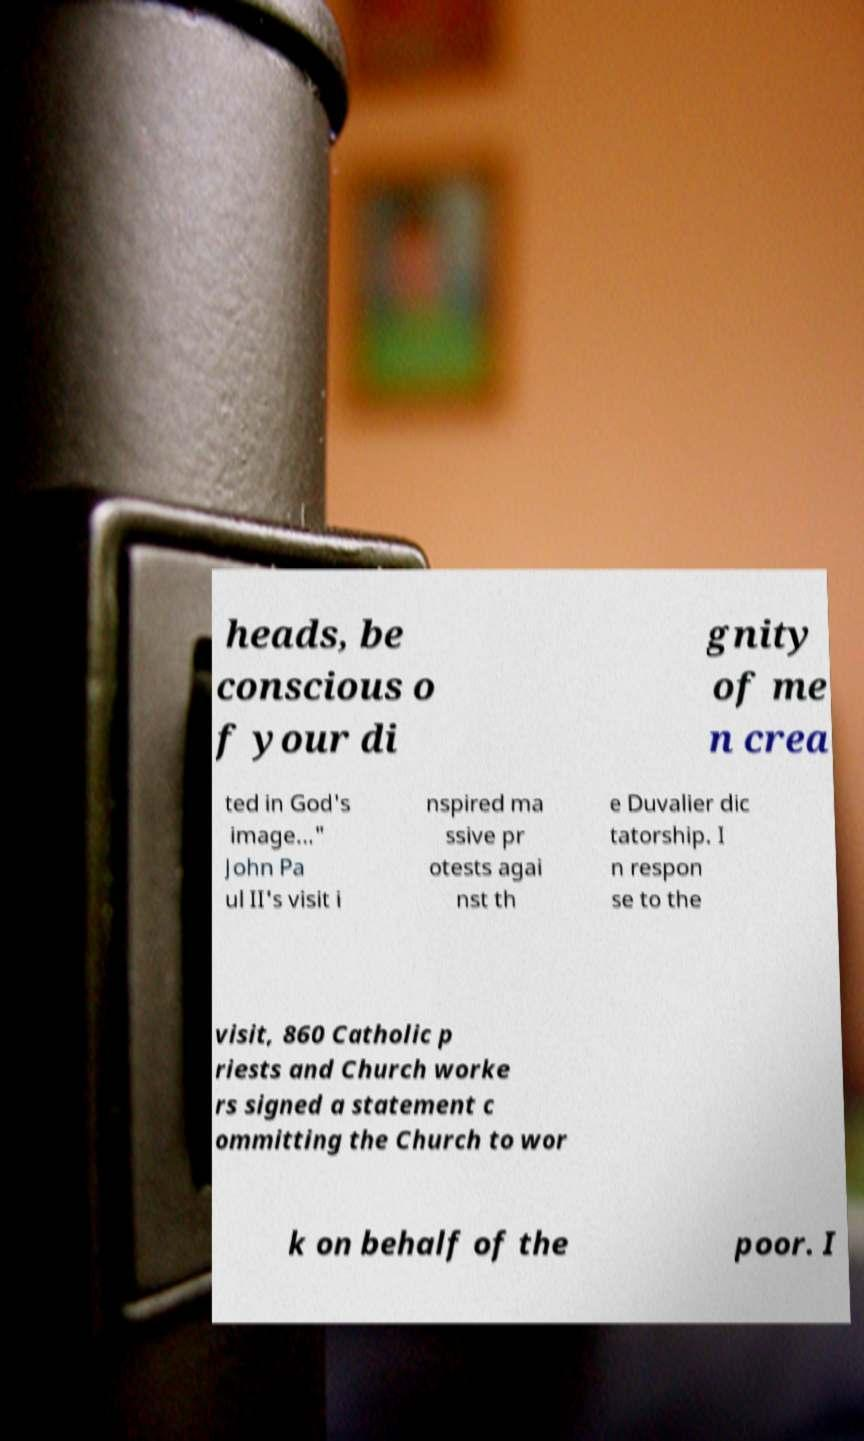Could you assist in decoding the text presented in this image and type it out clearly? heads, be conscious o f your di gnity of me n crea ted in God's image..." John Pa ul II's visit i nspired ma ssive pr otests agai nst th e Duvalier dic tatorship. I n respon se to the visit, 860 Catholic p riests and Church worke rs signed a statement c ommitting the Church to wor k on behalf of the poor. I 